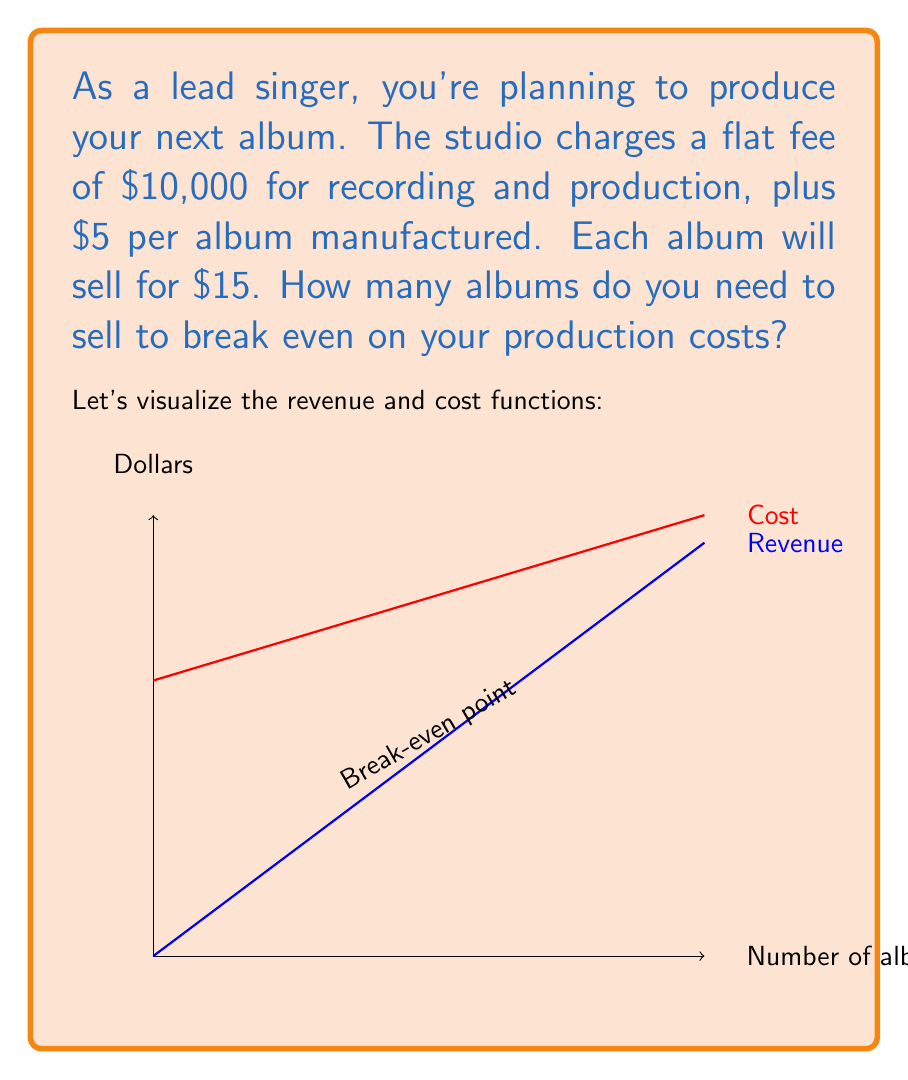Give your solution to this math problem. To solve this problem, we need to find the point where the total revenue equals the total cost. Let's break it down step-by-step:

1) Let $x$ be the number of albums sold.

2) Revenue function: 
   $R(x) = 15x$

3) Cost function: 
   $C(x) = 10000 + 5x$

4) At the break-even point, revenue equals cost:
   $R(x) = C(x)$

5) Substitute the functions:
   $15x = 10000 + 5x$

6) Solve for $x$:
   $15x - 5x = 10000$
   $10x = 10000$
   $x = 1000$

7) Verify:
   Revenue: $15 * 1000 = 15000$
   Cost: $10000 + 5 * 1000 = 15000$

Therefore, you need to sell 1000 albums to break even.
Answer: 1000 albums 